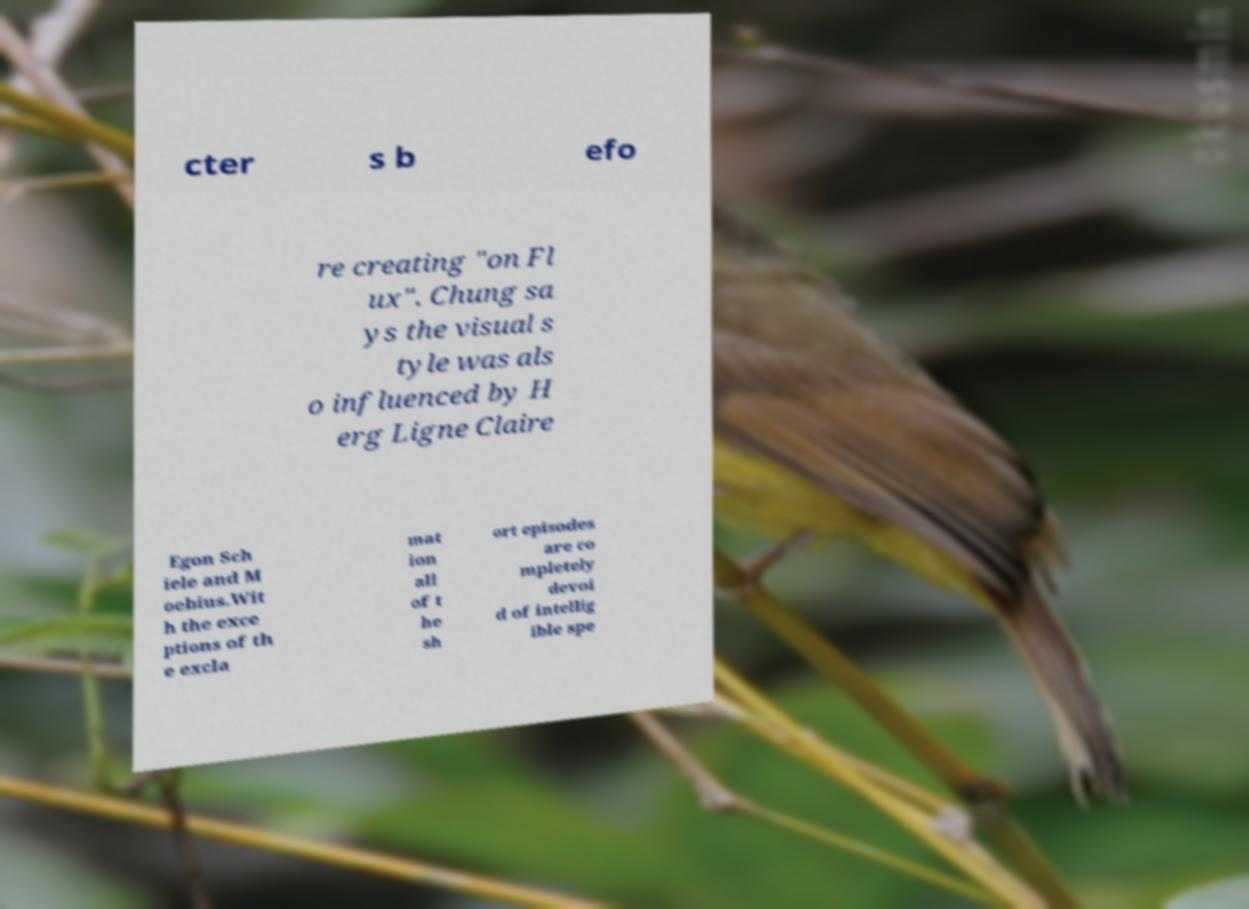Can you read and provide the text displayed in the image?This photo seems to have some interesting text. Can you extract and type it out for me? cter s b efo re creating "on Fl ux". Chung sa ys the visual s tyle was als o influenced by H erg Ligne Claire Egon Sch iele and M oebius.Wit h the exce ptions of th e excla mat ion all of t he sh ort episodes are co mpletely devoi d of intellig ible spe 